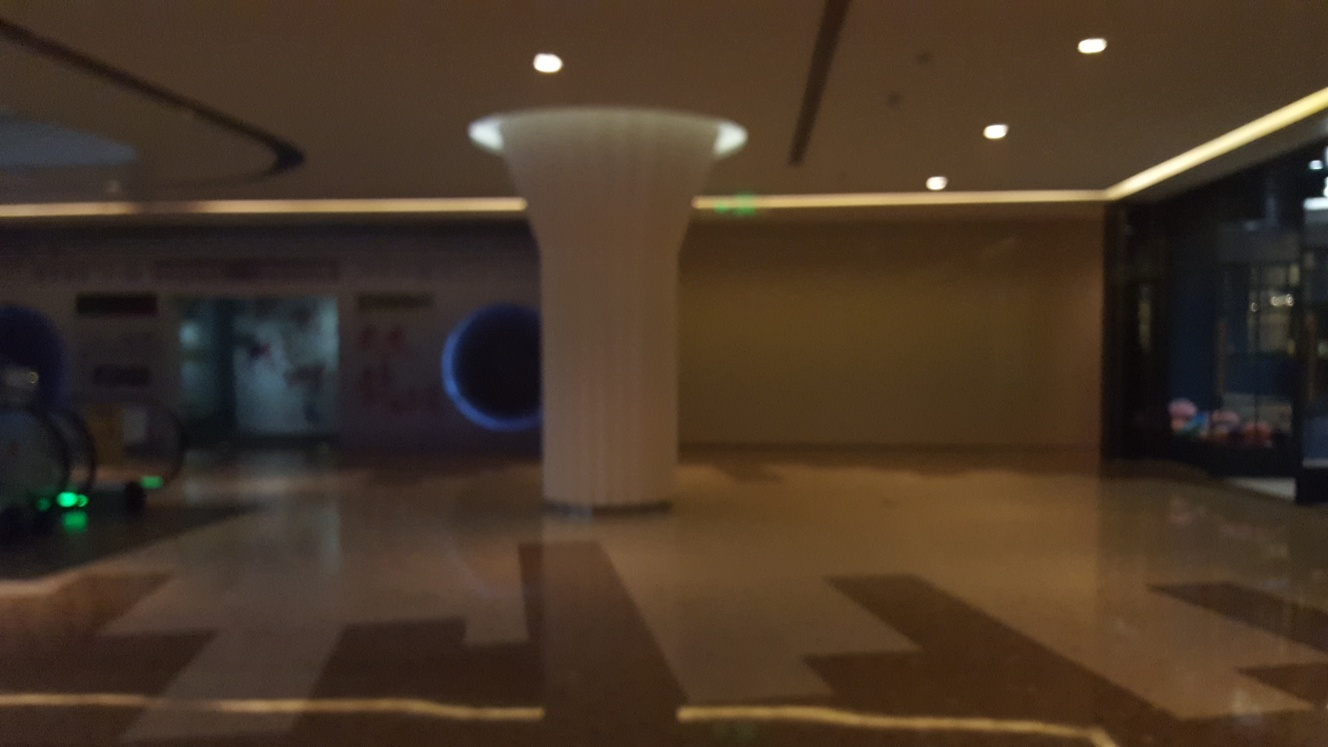Is the space currently occupied? There are no individuals visible in the image, so it appears unoccupied at the moment. However, the presence of infrastructure like a desk and indoor plants suggests it is a space that is meant for use, possibly during busier times. 